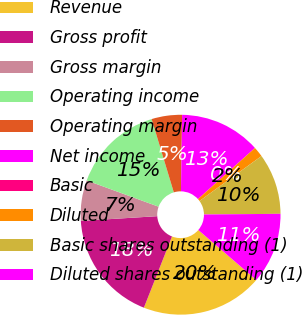Convert chart to OTSL. <chart><loc_0><loc_0><loc_500><loc_500><pie_chart><fcel>Revenue<fcel>Gross profit<fcel>Gross margin<fcel>Operating income<fcel>Operating margin<fcel>Net income<fcel>Basic<fcel>Diluted<fcel>Basic shares outstanding (1)<fcel>Diluted shares outstanding (1)<nl><fcel>19.66%<fcel>18.03%<fcel>6.56%<fcel>14.75%<fcel>4.92%<fcel>13.11%<fcel>0.01%<fcel>1.65%<fcel>9.84%<fcel>11.47%<nl></chart> 